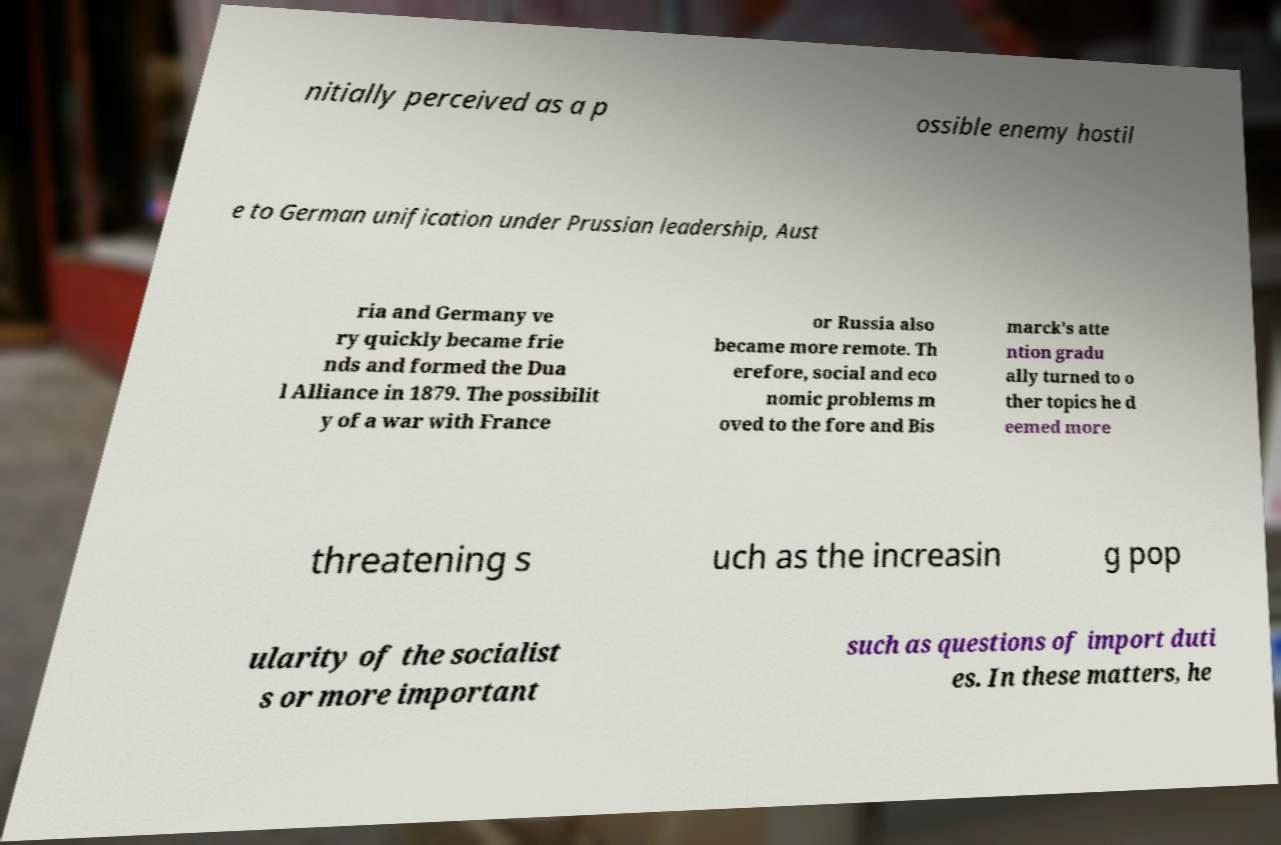I need the written content from this picture converted into text. Can you do that? nitially perceived as a p ossible enemy hostil e to German unification under Prussian leadership, Aust ria and Germany ve ry quickly became frie nds and formed the Dua l Alliance in 1879. The possibilit y of a war with France or Russia also became more remote. Th erefore, social and eco nomic problems m oved to the fore and Bis marck's atte ntion gradu ally turned to o ther topics he d eemed more threatening s uch as the increasin g pop ularity of the socialist s or more important such as questions of import duti es. In these matters, he 